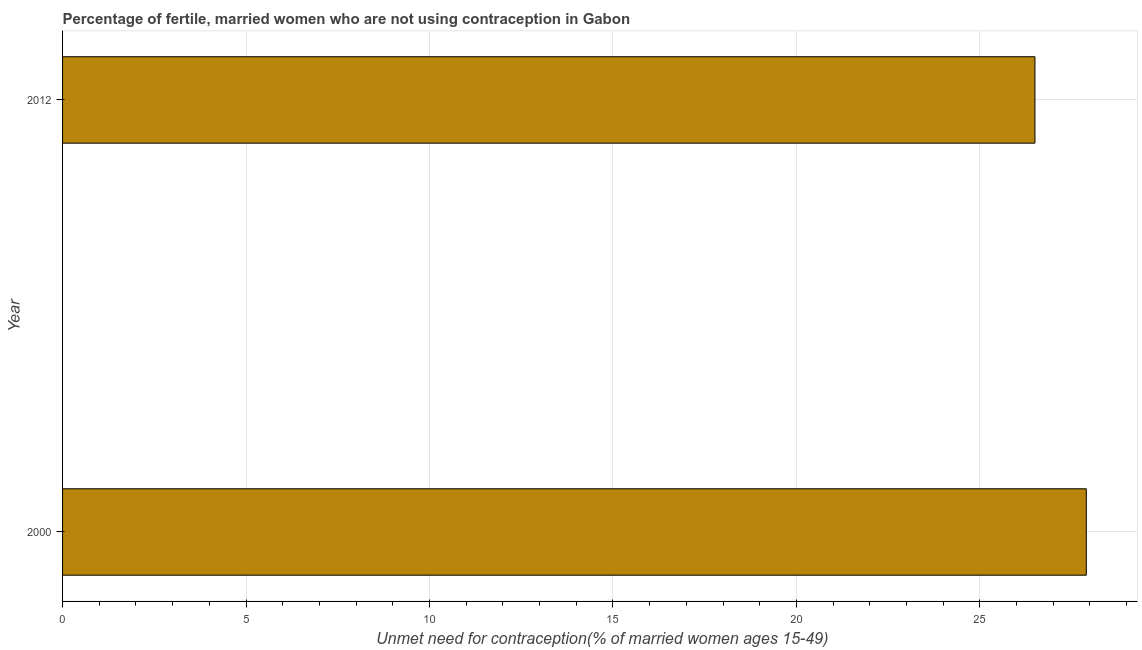Does the graph contain grids?
Make the answer very short. Yes. What is the title of the graph?
Make the answer very short. Percentage of fertile, married women who are not using contraception in Gabon. What is the label or title of the X-axis?
Offer a terse response.  Unmet need for contraception(% of married women ages 15-49). What is the label or title of the Y-axis?
Make the answer very short. Year. Across all years, what is the maximum number of married women who are not using contraception?
Give a very brief answer. 27.9. In which year was the number of married women who are not using contraception maximum?
Give a very brief answer. 2000. In which year was the number of married women who are not using contraception minimum?
Your answer should be very brief. 2012. What is the sum of the number of married women who are not using contraception?
Make the answer very short. 54.4. What is the difference between the number of married women who are not using contraception in 2000 and 2012?
Give a very brief answer. 1.4. What is the average number of married women who are not using contraception per year?
Give a very brief answer. 27.2. What is the median number of married women who are not using contraception?
Give a very brief answer. 27.2. In how many years, is the number of married women who are not using contraception greater than 15 %?
Keep it short and to the point. 2. Do a majority of the years between 2000 and 2012 (inclusive) have number of married women who are not using contraception greater than 6 %?
Provide a succinct answer. Yes. What is the ratio of the number of married women who are not using contraception in 2000 to that in 2012?
Make the answer very short. 1.05. Is the number of married women who are not using contraception in 2000 less than that in 2012?
Ensure brevity in your answer.  No. Are the values on the major ticks of X-axis written in scientific E-notation?
Keep it short and to the point. No. What is the  Unmet need for contraception(% of married women ages 15-49) of 2000?
Make the answer very short. 27.9. What is the  Unmet need for contraception(% of married women ages 15-49) of 2012?
Your answer should be very brief. 26.5. What is the difference between the  Unmet need for contraception(% of married women ages 15-49) in 2000 and 2012?
Offer a terse response. 1.4. What is the ratio of the  Unmet need for contraception(% of married women ages 15-49) in 2000 to that in 2012?
Your response must be concise. 1.05. 